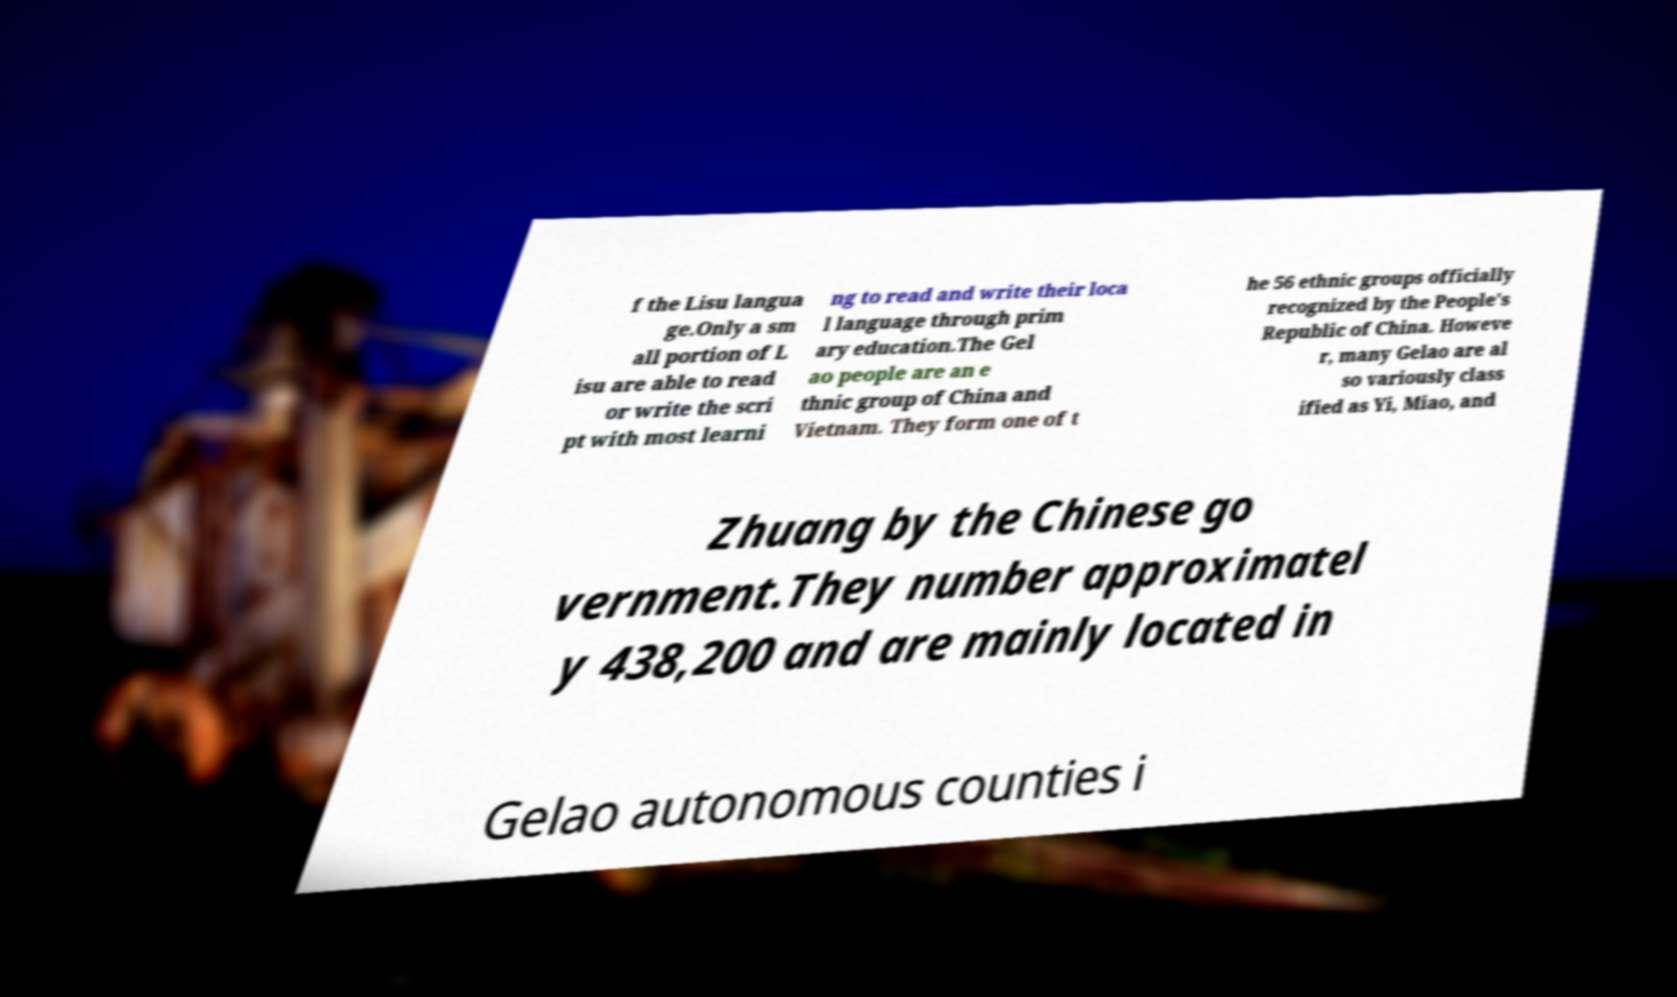Can you accurately transcribe the text from the provided image for me? f the Lisu langua ge.Only a sm all portion of L isu are able to read or write the scri pt with most learni ng to read and write their loca l language through prim ary education.The Gel ao people are an e thnic group of China and Vietnam. They form one of t he 56 ethnic groups officially recognized by the People's Republic of China. Howeve r, many Gelao are al so variously class ified as Yi, Miao, and Zhuang by the Chinese go vernment.They number approximatel y 438,200 and are mainly located in Gelao autonomous counties i 